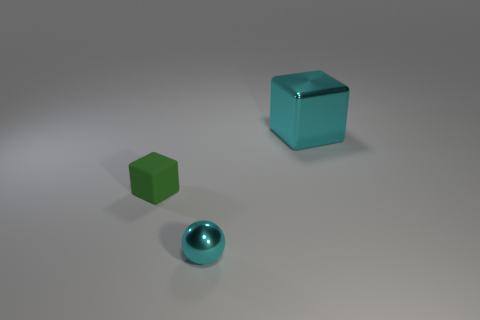How many other objects are the same size as the matte cube?
Ensure brevity in your answer.  1. The tiny rubber object is what color?
Offer a terse response. Green. What is the material of the block that is right of the ball?
Give a very brief answer. Metal. Is the number of green cubes that are in front of the cyan ball the same as the number of large green matte blocks?
Your answer should be very brief. Yes. Is the shape of the rubber thing the same as the large cyan thing?
Your answer should be very brief. Yes. Is there any other thing that has the same color as the tiny cube?
Your response must be concise. No. What shape is the thing that is in front of the large cyan thing and right of the tiny block?
Offer a very short reply. Sphere. Are there the same number of cyan things left of the tiny matte thing and large cyan metallic objects left of the tiny cyan ball?
Give a very brief answer. Yes. How many spheres are either small red metallic objects or cyan shiny things?
Provide a succinct answer. 1. What number of other cyan blocks are the same material as the big cube?
Your answer should be very brief. 0. 